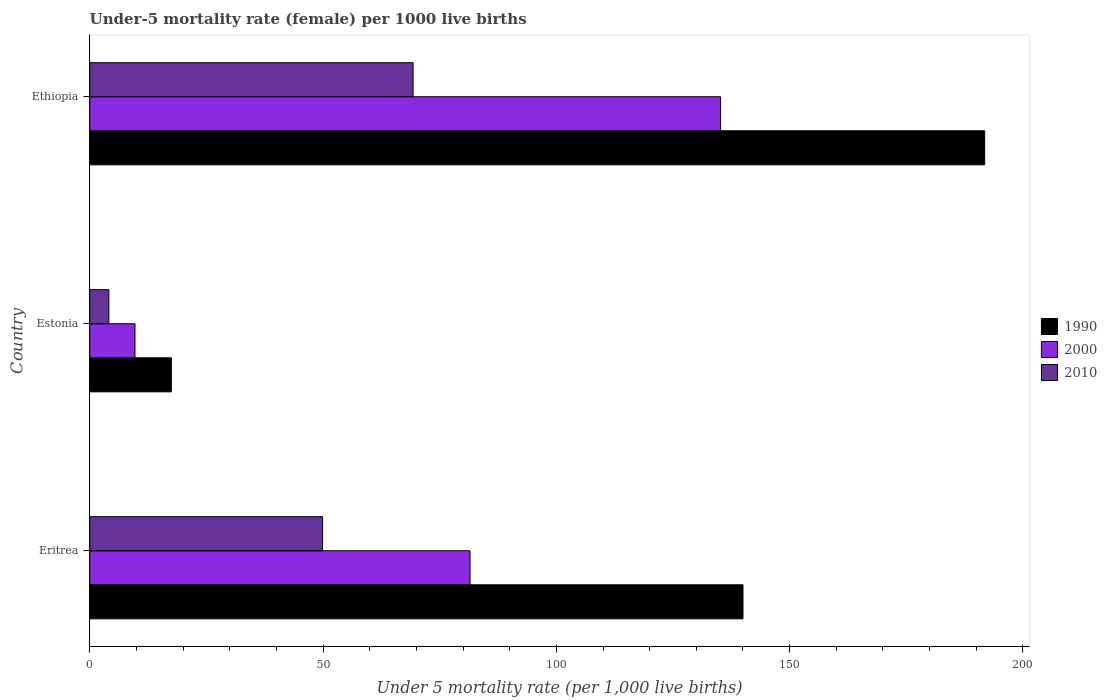How many different coloured bars are there?
Keep it short and to the point. 3. How many groups of bars are there?
Provide a succinct answer. 3. Are the number of bars per tick equal to the number of legend labels?
Keep it short and to the point. Yes. Are the number of bars on each tick of the Y-axis equal?
Your answer should be compact. Yes. What is the label of the 1st group of bars from the top?
Make the answer very short. Ethiopia. What is the under-five mortality rate in 2000 in Ethiopia?
Your answer should be compact. 135.2. Across all countries, what is the maximum under-five mortality rate in 1990?
Keep it short and to the point. 191.8. In which country was the under-five mortality rate in 2000 maximum?
Provide a succinct answer. Ethiopia. In which country was the under-five mortality rate in 2000 minimum?
Make the answer very short. Estonia. What is the total under-five mortality rate in 2010 in the graph?
Provide a succinct answer. 123.3. What is the difference between the under-five mortality rate in 1990 in Estonia and that in Ethiopia?
Your answer should be compact. -174.3. What is the difference between the under-five mortality rate in 1990 in Eritrea and the under-five mortality rate in 2010 in Ethiopia?
Your response must be concise. 70.7. What is the average under-five mortality rate in 1990 per country?
Provide a succinct answer. 116.43. What is the difference between the under-five mortality rate in 1990 and under-five mortality rate in 2000 in Eritrea?
Your answer should be very brief. 58.5. In how many countries, is the under-five mortality rate in 1990 greater than 100 ?
Give a very brief answer. 2. What is the ratio of the under-five mortality rate in 2000 in Eritrea to that in Ethiopia?
Your answer should be very brief. 0.6. What is the difference between the highest and the second highest under-five mortality rate in 2000?
Make the answer very short. 53.7. What is the difference between the highest and the lowest under-five mortality rate in 2010?
Keep it short and to the point. 65.2. In how many countries, is the under-five mortality rate in 1990 greater than the average under-five mortality rate in 1990 taken over all countries?
Give a very brief answer. 2. Is the sum of the under-five mortality rate in 2010 in Eritrea and Ethiopia greater than the maximum under-five mortality rate in 1990 across all countries?
Offer a very short reply. No. Does the graph contain any zero values?
Your response must be concise. No. Does the graph contain grids?
Provide a succinct answer. No. Where does the legend appear in the graph?
Your response must be concise. Center right. What is the title of the graph?
Your answer should be very brief. Under-5 mortality rate (female) per 1000 live births. Does "2001" appear as one of the legend labels in the graph?
Offer a very short reply. No. What is the label or title of the X-axis?
Offer a terse response. Under 5 mortality rate (per 1,0 live births). What is the Under 5 mortality rate (per 1,000 live births) of 1990 in Eritrea?
Provide a succinct answer. 140. What is the Under 5 mortality rate (per 1,000 live births) in 2000 in Eritrea?
Keep it short and to the point. 81.5. What is the Under 5 mortality rate (per 1,000 live births) in 2010 in Eritrea?
Provide a short and direct response. 49.9. What is the Under 5 mortality rate (per 1,000 live births) of 1990 in Estonia?
Your response must be concise. 17.5. What is the Under 5 mortality rate (per 1,000 live births) of 2000 in Estonia?
Your answer should be compact. 9.7. What is the Under 5 mortality rate (per 1,000 live births) of 2010 in Estonia?
Provide a succinct answer. 4.1. What is the Under 5 mortality rate (per 1,000 live births) in 1990 in Ethiopia?
Make the answer very short. 191.8. What is the Under 5 mortality rate (per 1,000 live births) in 2000 in Ethiopia?
Your response must be concise. 135.2. What is the Under 5 mortality rate (per 1,000 live births) in 2010 in Ethiopia?
Ensure brevity in your answer.  69.3. Across all countries, what is the maximum Under 5 mortality rate (per 1,000 live births) of 1990?
Keep it short and to the point. 191.8. Across all countries, what is the maximum Under 5 mortality rate (per 1,000 live births) in 2000?
Ensure brevity in your answer.  135.2. Across all countries, what is the maximum Under 5 mortality rate (per 1,000 live births) in 2010?
Your answer should be compact. 69.3. Across all countries, what is the minimum Under 5 mortality rate (per 1,000 live births) in 1990?
Provide a succinct answer. 17.5. What is the total Under 5 mortality rate (per 1,000 live births) of 1990 in the graph?
Provide a short and direct response. 349.3. What is the total Under 5 mortality rate (per 1,000 live births) of 2000 in the graph?
Your answer should be compact. 226.4. What is the total Under 5 mortality rate (per 1,000 live births) of 2010 in the graph?
Provide a succinct answer. 123.3. What is the difference between the Under 5 mortality rate (per 1,000 live births) in 1990 in Eritrea and that in Estonia?
Offer a very short reply. 122.5. What is the difference between the Under 5 mortality rate (per 1,000 live births) of 2000 in Eritrea and that in Estonia?
Offer a very short reply. 71.8. What is the difference between the Under 5 mortality rate (per 1,000 live births) of 2010 in Eritrea and that in Estonia?
Your response must be concise. 45.8. What is the difference between the Under 5 mortality rate (per 1,000 live births) in 1990 in Eritrea and that in Ethiopia?
Your response must be concise. -51.8. What is the difference between the Under 5 mortality rate (per 1,000 live births) of 2000 in Eritrea and that in Ethiopia?
Give a very brief answer. -53.7. What is the difference between the Under 5 mortality rate (per 1,000 live births) in 2010 in Eritrea and that in Ethiopia?
Your answer should be very brief. -19.4. What is the difference between the Under 5 mortality rate (per 1,000 live births) in 1990 in Estonia and that in Ethiopia?
Your answer should be compact. -174.3. What is the difference between the Under 5 mortality rate (per 1,000 live births) of 2000 in Estonia and that in Ethiopia?
Provide a short and direct response. -125.5. What is the difference between the Under 5 mortality rate (per 1,000 live births) in 2010 in Estonia and that in Ethiopia?
Make the answer very short. -65.2. What is the difference between the Under 5 mortality rate (per 1,000 live births) in 1990 in Eritrea and the Under 5 mortality rate (per 1,000 live births) in 2000 in Estonia?
Offer a very short reply. 130.3. What is the difference between the Under 5 mortality rate (per 1,000 live births) of 1990 in Eritrea and the Under 5 mortality rate (per 1,000 live births) of 2010 in Estonia?
Provide a succinct answer. 135.9. What is the difference between the Under 5 mortality rate (per 1,000 live births) in 2000 in Eritrea and the Under 5 mortality rate (per 1,000 live births) in 2010 in Estonia?
Make the answer very short. 77.4. What is the difference between the Under 5 mortality rate (per 1,000 live births) of 1990 in Eritrea and the Under 5 mortality rate (per 1,000 live births) of 2000 in Ethiopia?
Your answer should be compact. 4.8. What is the difference between the Under 5 mortality rate (per 1,000 live births) in 1990 in Eritrea and the Under 5 mortality rate (per 1,000 live births) in 2010 in Ethiopia?
Keep it short and to the point. 70.7. What is the difference between the Under 5 mortality rate (per 1,000 live births) in 1990 in Estonia and the Under 5 mortality rate (per 1,000 live births) in 2000 in Ethiopia?
Provide a short and direct response. -117.7. What is the difference between the Under 5 mortality rate (per 1,000 live births) in 1990 in Estonia and the Under 5 mortality rate (per 1,000 live births) in 2010 in Ethiopia?
Your answer should be compact. -51.8. What is the difference between the Under 5 mortality rate (per 1,000 live births) of 2000 in Estonia and the Under 5 mortality rate (per 1,000 live births) of 2010 in Ethiopia?
Your answer should be compact. -59.6. What is the average Under 5 mortality rate (per 1,000 live births) of 1990 per country?
Offer a terse response. 116.43. What is the average Under 5 mortality rate (per 1,000 live births) in 2000 per country?
Make the answer very short. 75.47. What is the average Under 5 mortality rate (per 1,000 live births) in 2010 per country?
Offer a terse response. 41.1. What is the difference between the Under 5 mortality rate (per 1,000 live births) in 1990 and Under 5 mortality rate (per 1,000 live births) in 2000 in Eritrea?
Your response must be concise. 58.5. What is the difference between the Under 5 mortality rate (per 1,000 live births) of 1990 and Under 5 mortality rate (per 1,000 live births) of 2010 in Eritrea?
Offer a terse response. 90.1. What is the difference between the Under 5 mortality rate (per 1,000 live births) in 2000 and Under 5 mortality rate (per 1,000 live births) in 2010 in Eritrea?
Make the answer very short. 31.6. What is the difference between the Under 5 mortality rate (per 1,000 live births) of 1990 and Under 5 mortality rate (per 1,000 live births) of 2000 in Estonia?
Give a very brief answer. 7.8. What is the difference between the Under 5 mortality rate (per 1,000 live births) of 2000 and Under 5 mortality rate (per 1,000 live births) of 2010 in Estonia?
Your answer should be compact. 5.6. What is the difference between the Under 5 mortality rate (per 1,000 live births) of 1990 and Under 5 mortality rate (per 1,000 live births) of 2000 in Ethiopia?
Ensure brevity in your answer.  56.6. What is the difference between the Under 5 mortality rate (per 1,000 live births) in 1990 and Under 5 mortality rate (per 1,000 live births) in 2010 in Ethiopia?
Offer a very short reply. 122.5. What is the difference between the Under 5 mortality rate (per 1,000 live births) in 2000 and Under 5 mortality rate (per 1,000 live births) in 2010 in Ethiopia?
Your response must be concise. 65.9. What is the ratio of the Under 5 mortality rate (per 1,000 live births) of 2000 in Eritrea to that in Estonia?
Your answer should be compact. 8.4. What is the ratio of the Under 5 mortality rate (per 1,000 live births) of 2010 in Eritrea to that in Estonia?
Your response must be concise. 12.17. What is the ratio of the Under 5 mortality rate (per 1,000 live births) in 1990 in Eritrea to that in Ethiopia?
Make the answer very short. 0.73. What is the ratio of the Under 5 mortality rate (per 1,000 live births) in 2000 in Eritrea to that in Ethiopia?
Provide a succinct answer. 0.6. What is the ratio of the Under 5 mortality rate (per 1,000 live births) of 2010 in Eritrea to that in Ethiopia?
Provide a short and direct response. 0.72. What is the ratio of the Under 5 mortality rate (per 1,000 live births) of 1990 in Estonia to that in Ethiopia?
Provide a succinct answer. 0.09. What is the ratio of the Under 5 mortality rate (per 1,000 live births) in 2000 in Estonia to that in Ethiopia?
Your response must be concise. 0.07. What is the ratio of the Under 5 mortality rate (per 1,000 live births) in 2010 in Estonia to that in Ethiopia?
Give a very brief answer. 0.06. What is the difference between the highest and the second highest Under 5 mortality rate (per 1,000 live births) in 1990?
Your answer should be very brief. 51.8. What is the difference between the highest and the second highest Under 5 mortality rate (per 1,000 live births) of 2000?
Provide a succinct answer. 53.7. What is the difference between the highest and the second highest Under 5 mortality rate (per 1,000 live births) in 2010?
Provide a succinct answer. 19.4. What is the difference between the highest and the lowest Under 5 mortality rate (per 1,000 live births) in 1990?
Your response must be concise. 174.3. What is the difference between the highest and the lowest Under 5 mortality rate (per 1,000 live births) of 2000?
Your response must be concise. 125.5. What is the difference between the highest and the lowest Under 5 mortality rate (per 1,000 live births) in 2010?
Your answer should be very brief. 65.2. 